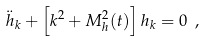Convert formula to latex. <formula><loc_0><loc_0><loc_500><loc_500>\ddot { h } _ { k } + \left [ k ^ { 2 } + M _ { h } ^ { 2 } ( t ) \right ] { h } _ { k } = 0 \ ,</formula> 